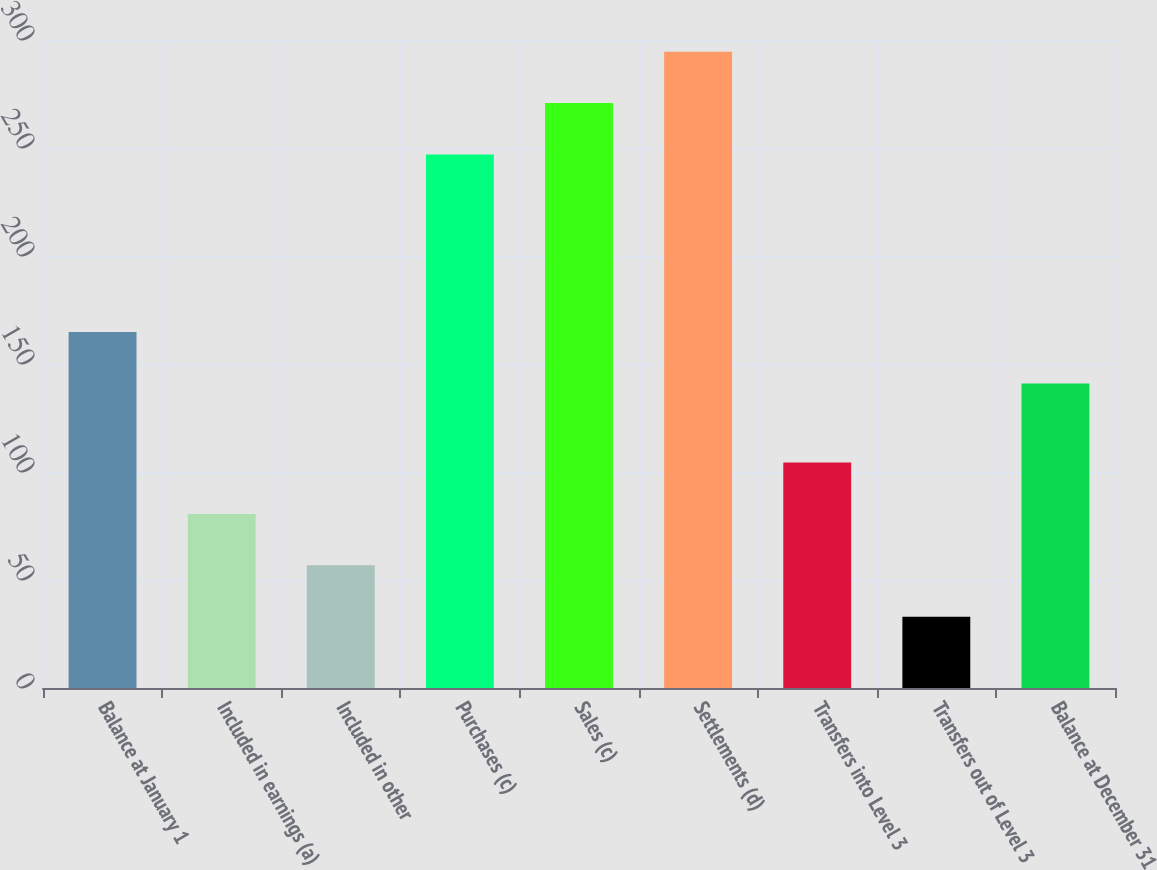Convert chart to OTSL. <chart><loc_0><loc_0><loc_500><loc_500><bar_chart><fcel>Balance at January 1<fcel>Included in earnings (a)<fcel>Included in other<fcel>Purchases (c)<fcel>Sales (c)<fcel>Settlements (d)<fcel>Transfers into Level 3<fcel>Transfers out of Level 3<fcel>Balance at December 31<nl><fcel>164.8<fcel>80.6<fcel>56.8<fcel>247<fcel>270.8<fcel>294.6<fcel>104.4<fcel>33<fcel>141<nl></chart> 